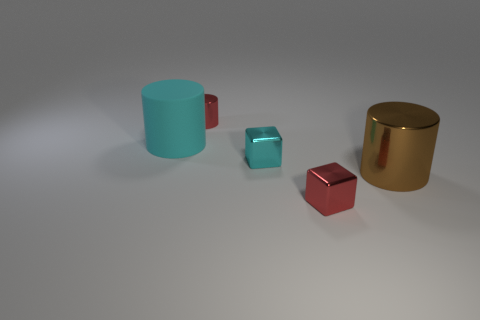Can you describe the different finishes on the objects and what their textures might feel like? Certainly! The objects display a variety of finishes: the cyan and gold cylinders have a smooth, glossy finish that would feel slick to the touch, while the red and cyan cubes have a reflective surface that might feel smooth and cold like polished metal. 